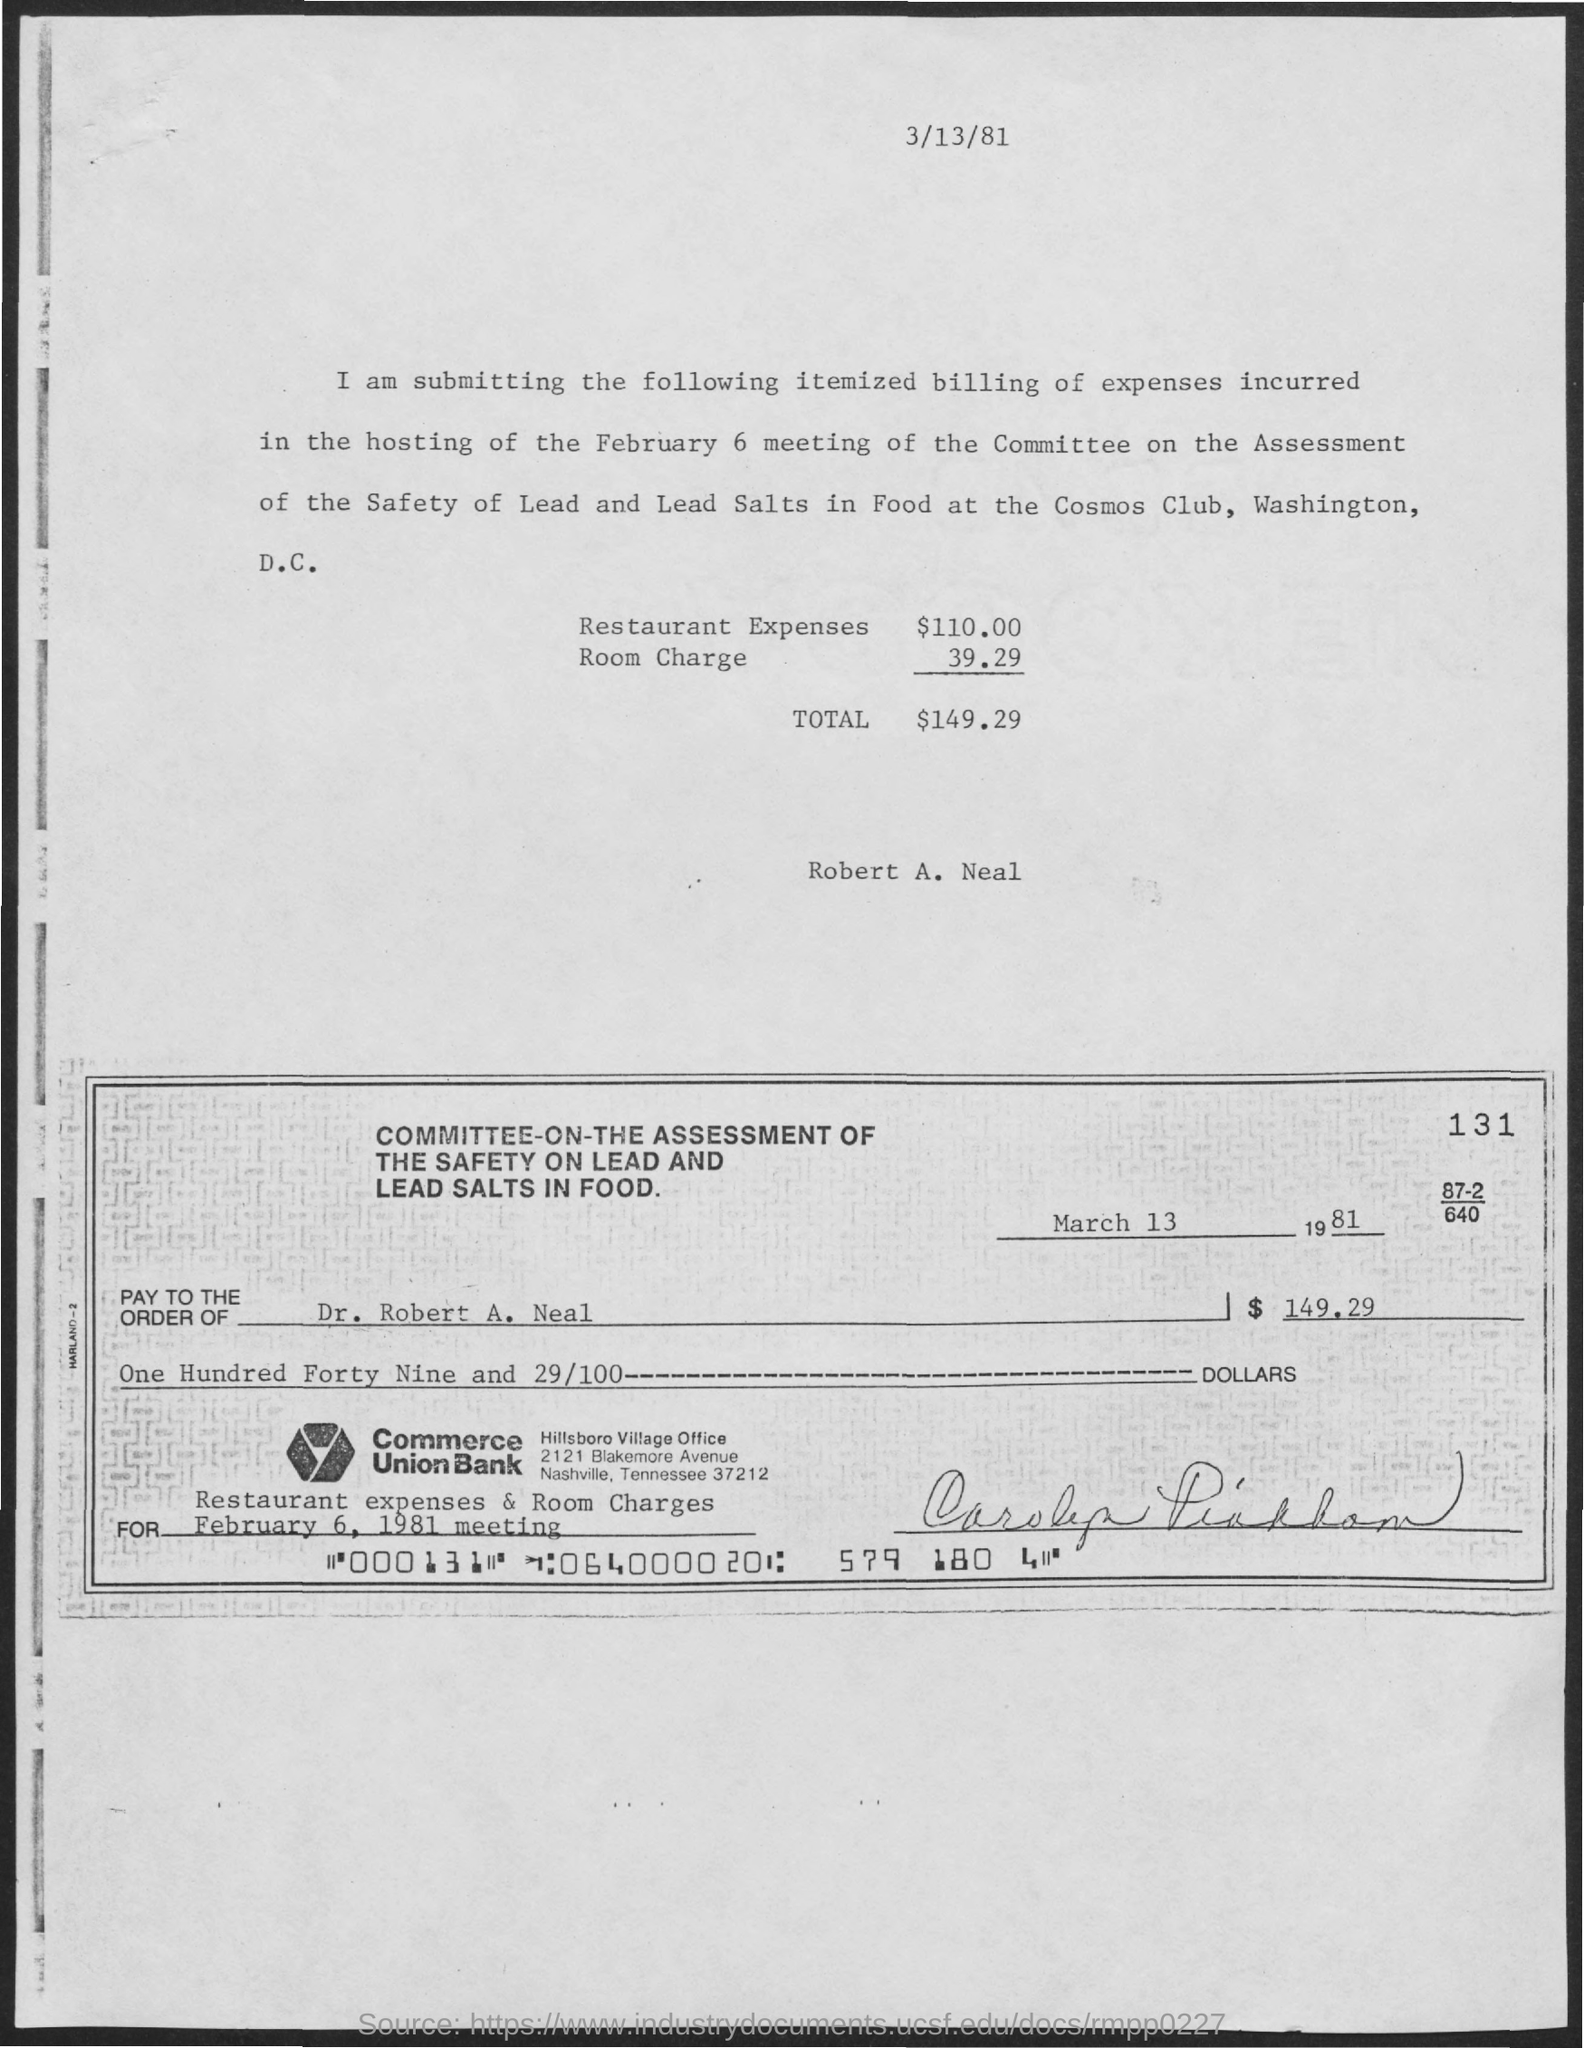What is the date mentioned in the given top of the  page ?
Your answer should be compact. 3/13/81. Whose name is given in the document above the cheque?
Give a very brief answer. Robert A. Neal. What is the total amount mentioned ?
Offer a terse response. $149.29. What is mentioned in the for ?
Your answer should be very brief. February 6, 1981 meeting. What is the check number?
Your answer should be very brief. 000131. 